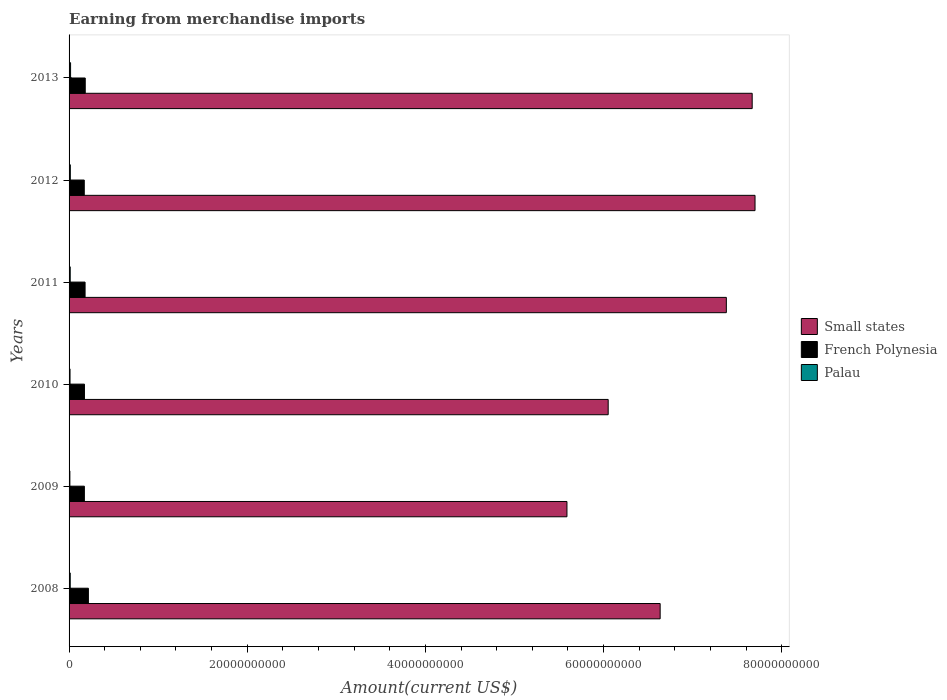How many different coloured bars are there?
Keep it short and to the point. 3. Are the number of bars on each tick of the Y-axis equal?
Your answer should be very brief. Yes. What is the amount earned from merchandise imports in Small states in 2008?
Your answer should be compact. 6.63e+1. Across all years, what is the maximum amount earned from merchandise imports in Small states?
Ensure brevity in your answer.  7.70e+1. Across all years, what is the minimum amount earned from merchandise imports in Small states?
Your answer should be compact. 5.59e+1. What is the total amount earned from merchandise imports in Palau in the graph?
Provide a short and direct response. 7.67e+08. What is the difference between the amount earned from merchandise imports in Small states in 2009 and that in 2011?
Offer a very short reply. -1.79e+1. What is the difference between the amount earned from merchandise imports in French Polynesia in 2009 and the amount earned from merchandise imports in Small states in 2013?
Provide a succinct answer. -7.50e+1. What is the average amount earned from merchandise imports in French Polynesia per year?
Your answer should be very brief. 1.82e+09. In the year 2013, what is the difference between the amount earned from merchandise imports in Small states and amount earned from merchandise imports in French Polynesia?
Offer a terse response. 7.49e+1. In how many years, is the amount earned from merchandise imports in Palau greater than 36000000000 US$?
Keep it short and to the point. 0. What is the ratio of the amount earned from merchandise imports in Small states in 2009 to that in 2012?
Offer a very short reply. 0.73. Is the amount earned from merchandise imports in Small states in 2009 less than that in 2011?
Ensure brevity in your answer.  Yes. What is the difference between the highest and the second highest amount earned from merchandise imports in French Polynesia?
Your answer should be compact. 3.54e+08. What is the difference between the highest and the lowest amount earned from merchandise imports in French Polynesia?
Provide a short and direct response. 4.63e+08. What does the 3rd bar from the top in 2013 represents?
Provide a succinct answer. Small states. What does the 1st bar from the bottom in 2011 represents?
Give a very brief answer. Small states. Is it the case that in every year, the sum of the amount earned from merchandise imports in Small states and amount earned from merchandise imports in French Polynesia is greater than the amount earned from merchandise imports in Palau?
Give a very brief answer. Yes. How many years are there in the graph?
Provide a succinct answer. 6. Are the values on the major ticks of X-axis written in scientific E-notation?
Ensure brevity in your answer.  No. Does the graph contain any zero values?
Ensure brevity in your answer.  No. Does the graph contain grids?
Your answer should be compact. No. How are the legend labels stacked?
Provide a short and direct response. Vertical. What is the title of the graph?
Your answer should be very brief. Earning from merchandise imports. What is the label or title of the X-axis?
Keep it short and to the point. Amount(current US$). What is the label or title of the Y-axis?
Your answer should be very brief. Years. What is the Amount(current US$) in Small states in 2008?
Give a very brief answer. 6.63e+1. What is the Amount(current US$) in French Polynesia in 2008?
Make the answer very short. 2.17e+09. What is the Amount(current US$) in Palau in 2008?
Your response must be concise. 1.30e+08. What is the Amount(current US$) in Small states in 2009?
Offer a very short reply. 5.59e+1. What is the Amount(current US$) in French Polynesia in 2009?
Your answer should be very brief. 1.72e+09. What is the Amount(current US$) in Palau in 2009?
Offer a very short reply. 8.99e+07. What is the Amount(current US$) of Small states in 2010?
Ensure brevity in your answer.  6.05e+1. What is the Amount(current US$) of French Polynesia in 2010?
Your response must be concise. 1.73e+09. What is the Amount(current US$) in Palau in 2010?
Provide a short and direct response. 1.07e+08. What is the Amount(current US$) in Small states in 2011?
Provide a succinct answer. 7.38e+1. What is the Amount(current US$) in French Polynesia in 2011?
Make the answer very short. 1.80e+09. What is the Amount(current US$) in Palau in 2011?
Give a very brief answer. 1.29e+08. What is the Amount(current US$) of Small states in 2012?
Your answer should be very brief. 7.70e+1. What is the Amount(current US$) of French Polynesia in 2012?
Provide a short and direct response. 1.71e+09. What is the Amount(current US$) in Palau in 2012?
Ensure brevity in your answer.  1.42e+08. What is the Amount(current US$) of Small states in 2013?
Keep it short and to the point. 7.67e+1. What is the Amount(current US$) in French Polynesia in 2013?
Your answer should be compact. 1.81e+09. What is the Amount(current US$) of Palau in 2013?
Make the answer very short. 1.69e+08. Across all years, what is the maximum Amount(current US$) in Small states?
Provide a short and direct response. 7.70e+1. Across all years, what is the maximum Amount(current US$) of French Polynesia?
Keep it short and to the point. 2.17e+09. Across all years, what is the maximum Amount(current US$) in Palau?
Your answer should be compact. 1.69e+08. Across all years, what is the minimum Amount(current US$) in Small states?
Your answer should be compact. 5.59e+1. Across all years, what is the minimum Amount(current US$) in French Polynesia?
Ensure brevity in your answer.  1.71e+09. Across all years, what is the minimum Amount(current US$) of Palau?
Keep it short and to the point. 8.99e+07. What is the total Amount(current US$) in Small states in the graph?
Your response must be concise. 4.10e+11. What is the total Amount(current US$) of French Polynesia in the graph?
Offer a terse response. 1.09e+1. What is the total Amount(current US$) in Palau in the graph?
Your answer should be very brief. 7.67e+08. What is the difference between the Amount(current US$) in Small states in 2008 and that in 2009?
Make the answer very short. 1.05e+1. What is the difference between the Amount(current US$) in French Polynesia in 2008 and that in 2009?
Offer a very short reply. 4.52e+08. What is the difference between the Amount(current US$) in Palau in 2008 and that in 2009?
Offer a very short reply. 4.02e+07. What is the difference between the Amount(current US$) in Small states in 2008 and that in 2010?
Your response must be concise. 5.83e+09. What is the difference between the Amount(current US$) in French Polynesia in 2008 and that in 2010?
Give a very brief answer. 4.43e+08. What is the difference between the Amount(current US$) of Palau in 2008 and that in 2010?
Give a very brief answer. 2.29e+07. What is the difference between the Amount(current US$) in Small states in 2008 and that in 2011?
Provide a succinct answer. -7.43e+09. What is the difference between the Amount(current US$) in French Polynesia in 2008 and that in 2011?
Keep it short and to the point. 3.72e+08. What is the difference between the Amount(current US$) of Palau in 2008 and that in 2011?
Provide a short and direct response. 9.13e+05. What is the difference between the Amount(current US$) of Small states in 2008 and that in 2012?
Give a very brief answer. -1.06e+1. What is the difference between the Amount(current US$) of French Polynesia in 2008 and that in 2012?
Your response must be concise. 4.63e+08. What is the difference between the Amount(current US$) in Palau in 2008 and that in 2012?
Your answer should be compact. -1.18e+07. What is the difference between the Amount(current US$) of Small states in 2008 and that in 2013?
Provide a short and direct response. -1.03e+1. What is the difference between the Amount(current US$) of French Polynesia in 2008 and that in 2013?
Give a very brief answer. 3.54e+08. What is the difference between the Amount(current US$) in Palau in 2008 and that in 2013?
Make the answer very short. -3.85e+07. What is the difference between the Amount(current US$) in Small states in 2009 and that in 2010?
Provide a succinct answer. -4.63e+09. What is the difference between the Amount(current US$) of French Polynesia in 2009 and that in 2010?
Provide a short and direct response. -8.70e+06. What is the difference between the Amount(current US$) of Palau in 2009 and that in 2010?
Make the answer very short. -1.73e+07. What is the difference between the Amount(current US$) in Small states in 2009 and that in 2011?
Make the answer very short. -1.79e+1. What is the difference between the Amount(current US$) in French Polynesia in 2009 and that in 2011?
Provide a short and direct response. -7.94e+07. What is the difference between the Amount(current US$) in Palau in 2009 and that in 2011?
Give a very brief answer. -3.93e+07. What is the difference between the Amount(current US$) in Small states in 2009 and that in 2012?
Ensure brevity in your answer.  -2.11e+1. What is the difference between the Amount(current US$) of French Polynesia in 2009 and that in 2012?
Provide a succinct answer. 1.16e+07. What is the difference between the Amount(current US$) of Palau in 2009 and that in 2012?
Give a very brief answer. -5.20e+07. What is the difference between the Amount(current US$) in Small states in 2009 and that in 2013?
Your answer should be very brief. -2.08e+1. What is the difference between the Amount(current US$) of French Polynesia in 2009 and that in 2013?
Give a very brief answer. -9.78e+07. What is the difference between the Amount(current US$) of Palau in 2009 and that in 2013?
Your response must be concise. -7.87e+07. What is the difference between the Amount(current US$) of Small states in 2010 and that in 2011?
Provide a succinct answer. -1.33e+1. What is the difference between the Amount(current US$) of French Polynesia in 2010 and that in 2011?
Keep it short and to the point. -7.07e+07. What is the difference between the Amount(current US$) of Palau in 2010 and that in 2011?
Offer a very short reply. -2.20e+07. What is the difference between the Amount(current US$) of Small states in 2010 and that in 2012?
Offer a terse response. -1.65e+1. What is the difference between the Amount(current US$) of French Polynesia in 2010 and that in 2012?
Offer a very short reply. 2.03e+07. What is the difference between the Amount(current US$) in Palau in 2010 and that in 2012?
Your answer should be very brief. -3.47e+07. What is the difference between the Amount(current US$) of Small states in 2010 and that in 2013?
Make the answer very short. -1.62e+1. What is the difference between the Amount(current US$) in French Polynesia in 2010 and that in 2013?
Your answer should be compact. -8.91e+07. What is the difference between the Amount(current US$) in Palau in 2010 and that in 2013?
Keep it short and to the point. -6.14e+07. What is the difference between the Amount(current US$) of Small states in 2011 and that in 2012?
Provide a short and direct response. -3.22e+09. What is the difference between the Amount(current US$) in French Polynesia in 2011 and that in 2012?
Offer a terse response. 9.10e+07. What is the difference between the Amount(current US$) of Palau in 2011 and that in 2012?
Make the answer very short. -1.27e+07. What is the difference between the Amount(current US$) of Small states in 2011 and that in 2013?
Offer a terse response. -2.90e+09. What is the difference between the Amount(current US$) in French Polynesia in 2011 and that in 2013?
Provide a short and direct response. -1.84e+07. What is the difference between the Amount(current US$) in Palau in 2011 and that in 2013?
Offer a terse response. -3.94e+07. What is the difference between the Amount(current US$) of Small states in 2012 and that in 2013?
Your response must be concise. 3.20e+08. What is the difference between the Amount(current US$) of French Polynesia in 2012 and that in 2013?
Your response must be concise. -1.09e+08. What is the difference between the Amount(current US$) in Palau in 2012 and that in 2013?
Offer a terse response. -2.67e+07. What is the difference between the Amount(current US$) of Small states in 2008 and the Amount(current US$) of French Polynesia in 2009?
Provide a short and direct response. 6.46e+1. What is the difference between the Amount(current US$) of Small states in 2008 and the Amount(current US$) of Palau in 2009?
Your response must be concise. 6.63e+1. What is the difference between the Amount(current US$) in French Polynesia in 2008 and the Amount(current US$) in Palau in 2009?
Your answer should be very brief. 2.08e+09. What is the difference between the Amount(current US$) of Small states in 2008 and the Amount(current US$) of French Polynesia in 2010?
Offer a very short reply. 6.46e+1. What is the difference between the Amount(current US$) in Small states in 2008 and the Amount(current US$) in Palau in 2010?
Keep it short and to the point. 6.62e+1. What is the difference between the Amount(current US$) in French Polynesia in 2008 and the Amount(current US$) in Palau in 2010?
Offer a very short reply. 2.06e+09. What is the difference between the Amount(current US$) of Small states in 2008 and the Amount(current US$) of French Polynesia in 2011?
Make the answer very short. 6.46e+1. What is the difference between the Amount(current US$) in Small states in 2008 and the Amount(current US$) in Palau in 2011?
Give a very brief answer. 6.62e+1. What is the difference between the Amount(current US$) of French Polynesia in 2008 and the Amount(current US$) of Palau in 2011?
Provide a short and direct response. 2.04e+09. What is the difference between the Amount(current US$) of Small states in 2008 and the Amount(current US$) of French Polynesia in 2012?
Provide a short and direct response. 6.46e+1. What is the difference between the Amount(current US$) of Small states in 2008 and the Amount(current US$) of Palau in 2012?
Offer a very short reply. 6.62e+1. What is the difference between the Amount(current US$) of French Polynesia in 2008 and the Amount(current US$) of Palau in 2012?
Your response must be concise. 2.03e+09. What is the difference between the Amount(current US$) in Small states in 2008 and the Amount(current US$) in French Polynesia in 2013?
Keep it short and to the point. 6.45e+1. What is the difference between the Amount(current US$) of Small states in 2008 and the Amount(current US$) of Palau in 2013?
Your answer should be very brief. 6.62e+1. What is the difference between the Amount(current US$) of French Polynesia in 2008 and the Amount(current US$) of Palau in 2013?
Offer a very short reply. 2.00e+09. What is the difference between the Amount(current US$) of Small states in 2009 and the Amount(current US$) of French Polynesia in 2010?
Provide a succinct answer. 5.42e+1. What is the difference between the Amount(current US$) in Small states in 2009 and the Amount(current US$) in Palau in 2010?
Offer a very short reply. 5.58e+1. What is the difference between the Amount(current US$) in French Polynesia in 2009 and the Amount(current US$) in Palau in 2010?
Your answer should be compact. 1.61e+09. What is the difference between the Amount(current US$) in Small states in 2009 and the Amount(current US$) in French Polynesia in 2011?
Provide a short and direct response. 5.41e+1. What is the difference between the Amount(current US$) in Small states in 2009 and the Amount(current US$) in Palau in 2011?
Your answer should be very brief. 5.58e+1. What is the difference between the Amount(current US$) of French Polynesia in 2009 and the Amount(current US$) of Palau in 2011?
Provide a succinct answer. 1.59e+09. What is the difference between the Amount(current US$) in Small states in 2009 and the Amount(current US$) in French Polynesia in 2012?
Keep it short and to the point. 5.42e+1. What is the difference between the Amount(current US$) in Small states in 2009 and the Amount(current US$) in Palau in 2012?
Ensure brevity in your answer.  5.57e+1. What is the difference between the Amount(current US$) of French Polynesia in 2009 and the Amount(current US$) of Palau in 2012?
Your answer should be compact. 1.58e+09. What is the difference between the Amount(current US$) of Small states in 2009 and the Amount(current US$) of French Polynesia in 2013?
Ensure brevity in your answer.  5.41e+1. What is the difference between the Amount(current US$) of Small states in 2009 and the Amount(current US$) of Palau in 2013?
Provide a short and direct response. 5.57e+1. What is the difference between the Amount(current US$) in French Polynesia in 2009 and the Amount(current US$) in Palau in 2013?
Keep it short and to the point. 1.55e+09. What is the difference between the Amount(current US$) in Small states in 2010 and the Amount(current US$) in French Polynesia in 2011?
Offer a very short reply. 5.87e+1. What is the difference between the Amount(current US$) of Small states in 2010 and the Amount(current US$) of Palau in 2011?
Your answer should be compact. 6.04e+1. What is the difference between the Amount(current US$) of French Polynesia in 2010 and the Amount(current US$) of Palau in 2011?
Give a very brief answer. 1.60e+09. What is the difference between the Amount(current US$) in Small states in 2010 and the Amount(current US$) in French Polynesia in 2012?
Your response must be concise. 5.88e+1. What is the difference between the Amount(current US$) of Small states in 2010 and the Amount(current US$) of Palau in 2012?
Keep it short and to the point. 6.04e+1. What is the difference between the Amount(current US$) in French Polynesia in 2010 and the Amount(current US$) in Palau in 2012?
Provide a short and direct response. 1.58e+09. What is the difference between the Amount(current US$) in Small states in 2010 and the Amount(current US$) in French Polynesia in 2013?
Ensure brevity in your answer.  5.87e+1. What is the difference between the Amount(current US$) of Small states in 2010 and the Amount(current US$) of Palau in 2013?
Provide a succinct answer. 6.03e+1. What is the difference between the Amount(current US$) of French Polynesia in 2010 and the Amount(current US$) of Palau in 2013?
Your answer should be very brief. 1.56e+09. What is the difference between the Amount(current US$) in Small states in 2011 and the Amount(current US$) in French Polynesia in 2012?
Provide a succinct answer. 7.21e+1. What is the difference between the Amount(current US$) in Small states in 2011 and the Amount(current US$) in Palau in 2012?
Provide a short and direct response. 7.36e+1. What is the difference between the Amount(current US$) in French Polynesia in 2011 and the Amount(current US$) in Palau in 2012?
Your answer should be compact. 1.65e+09. What is the difference between the Amount(current US$) of Small states in 2011 and the Amount(current US$) of French Polynesia in 2013?
Offer a terse response. 7.20e+1. What is the difference between the Amount(current US$) in Small states in 2011 and the Amount(current US$) in Palau in 2013?
Offer a terse response. 7.36e+1. What is the difference between the Amount(current US$) of French Polynesia in 2011 and the Amount(current US$) of Palau in 2013?
Offer a very short reply. 1.63e+09. What is the difference between the Amount(current US$) in Small states in 2012 and the Amount(current US$) in French Polynesia in 2013?
Your answer should be compact. 7.52e+1. What is the difference between the Amount(current US$) in Small states in 2012 and the Amount(current US$) in Palau in 2013?
Make the answer very short. 7.68e+1. What is the difference between the Amount(current US$) in French Polynesia in 2012 and the Amount(current US$) in Palau in 2013?
Provide a succinct answer. 1.54e+09. What is the average Amount(current US$) of Small states per year?
Ensure brevity in your answer.  6.84e+1. What is the average Amount(current US$) in French Polynesia per year?
Your answer should be very brief. 1.82e+09. What is the average Amount(current US$) in Palau per year?
Ensure brevity in your answer.  1.28e+08. In the year 2008, what is the difference between the Amount(current US$) of Small states and Amount(current US$) of French Polynesia?
Your answer should be very brief. 6.42e+1. In the year 2008, what is the difference between the Amount(current US$) of Small states and Amount(current US$) of Palau?
Make the answer very short. 6.62e+1. In the year 2008, what is the difference between the Amount(current US$) of French Polynesia and Amount(current US$) of Palau?
Keep it short and to the point. 2.04e+09. In the year 2009, what is the difference between the Amount(current US$) of Small states and Amount(current US$) of French Polynesia?
Offer a very short reply. 5.42e+1. In the year 2009, what is the difference between the Amount(current US$) of Small states and Amount(current US$) of Palau?
Your response must be concise. 5.58e+1. In the year 2009, what is the difference between the Amount(current US$) in French Polynesia and Amount(current US$) in Palau?
Your response must be concise. 1.63e+09. In the year 2010, what is the difference between the Amount(current US$) of Small states and Amount(current US$) of French Polynesia?
Ensure brevity in your answer.  5.88e+1. In the year 2010, what is the difference between the Amount(current US$) in Small states and Amount(current US$) in Palau?
Offer a very short reply. 6.04e+1. In the year 2010, what is the difference between the Amount(current US$) in French Polynesia and Amount(current US$) in Palau?
Your answer should be very brief. 1.62e+09. In the year 2011, what is the difference between the Amount(current US$) of Small states and Amount(current US$) of French Polynesia?
Your answer should be compact. 7.20e+1. In the year 2011, what is the difference between the Amount(current US$) of Small states and Amount(current US$) of Palau?
Offer a terse response. 7.36e+1. In the year 2011, what is the difference between the Amount(current US$) of French Polynesia and Amount(current US$) of Palau?
Give a very brief answer. 1.67e+09. In the year 2012, what is the difference between the Amount(current US$) in Small states and Amount(current US$) in French Polynesia?
Offer a terse response. 7.53e+1. In the year 2012, what is the difference between the Amount(current US$) of Small states and Amount(current US$) of Palau?
Your response must be concise. 7.69e+1. In the year 2012, what is the difference between the Amount(current US$) in French Polynesia and Amount(current US$) in Palau?
Ensure brevity in your answer.  1.56e+09. In the year 2013, what is the difference between the Amount(current US$) in Small states and Amount(current US$) in French Polynesia?
Give a very brief answer. 7.49e+1. In the year 2013, what is the difference between the Amount(current US$) in Small states and Amount(current US$) in Palau?
Keep it short and to the point. 7.65e+1. In the year 2013, what is the difference between the Amount(current US$) in French Polynesia and Amount(current US$) in Palau?
Give a very brief answer. 1.65e+09. What is the ratio of the Amount(current US$) of Small states in 2008 to that in 2009?
Your response must be concise. 1.19. What is the ratio of the Amount(current US$) of French Polynesia in 2008 to that in 2009?
Provide a short and direct response. 1.26. What is the ratio of the Amount(current US$) in Palau in 2008 to that in 2009?
Ensure brevity in your answer.  1.45. What is the ratio of the Amount(current US$) of Small states in 2008 to that in 2010?
Give a very brief answer. 1.1. What is the ratio of the Amount(current US$) of French Polynesia in 2008 to that in 2010?
Your answer should be very brief. 1.26. What is the ratio of the Amount(current US$) of Palau in 2008 to that in 2010?
Provide a succinct answer. 1.21. What is the ratio of the Amount(current US$) in Small states in 2008 to that in 2011?
Provide a short and direct response. 0.9. What is the ratio of the Amount(current US$) of French Polynesia in 2008 to that in 2011?
Ensure brevity in your answer.  1.21. What is the ratio of the Amount(current US$) of Palau in 2008 to that in 2011?
Ensure brevity in your answer.  1.01. What is the ratio of the Amount(current US$) in Small states in 2008 to that in 2012?
Offer a very short reply. 0.86. What is the ratio of the Amount(current US$) in French Polynesia in 2008 to that in 2012?
Keep it short and to the point. 1.27. What is the ratio of the Amount(current US$) in Palau in 2008 to that in 2012?
Provide a succinct answer. 0.92. What is the ratio of the Amount(current US$) of Small states in 2008 to that in 2013?
Your answer should be very brief. 0.87. What is the ratio of the Amount(current US$) of French Polynesia in 2008 to that in 2013?
Provide a succinct answer. 1.2. What is the ratio of the Amount(current US$) in Palau in 2008 to that in 2013?
Ensure brevity in your answer.  0.77. What is the ratio of the Amount(current US$) of Small states in 2009 to that in 2010?
Keep it short and to the point. 0.92. What is the ratio of the Amount(current US$) in Palau in 2009 to that in 2010?
Your answer should be compact. 0.84. What is the ratio of the Amount(current US$) of Small states in 2009 to that in 2011?
Provide a succinct answer. 0.76. What is the ratio of the Amount(current US$) in French Polynesia in 2009 to that in 2011?
Provide a short and direct response. 0.96. What is the ratio of the Amount(current US$) in Palau in 2009 to that in 2011?
Provide a succinct answer. 0.7. What is the ratio of the Amount(current US$) of Small states in 2009 to that in 2012?
Your answer should be very brief. 0.73. What is the ratio of the Amount(current US$) in French Polynesia in 2009 to that in 2012?
Keep it short and to the point. 1.01. What is the ratio of the Amount(current US$) of Palau in 2009 to that in 2012?
Offer a terse response. 0.63. What is the ratio of the Amount(current US$) in Small states in 2009 to that in 2013?
Offer a terse response. 0.73. What is the ratio of the Amount(current US$) of French Polynesia in 2009 to that in 2013?
Your answer should be very brief. 0.95. What is the ratio of the Amount(current US$) in Palau in 2009 to that in 2013?
Give a very brief answer. 0.53. What is the ratio of the Amount(current US$) of Small states in 2010 to that in 2011?
Offer a terse response. 0.82. What is the ratio of the Amount(current US$) of French Polynesia in 2010 to that in 2011?
Offer a terse response. 0.96. What is the ratio of the Amount(current US$) in Palau in 2010 to that in 2011?
Offer a terse response. 0.83. What is the ratio of the Amount(current US$) in Small states in 2010 to that in 2012?
Offer a very short reply. 0.79. What is the ratio of the Amount(current US$) in French Polynesia in 2010 to that in 2012?
Make the answer very short. 1.01. What is the ratio of the Amount(current US$) in Palau in 2010 to that in 2012?
Provide a succinct answer. 0.76. What is the ratio of the Amount(current US$) of Small states in 2010 to that in 2013?
Your response must be concise. 0.79. What is the ratio of the Amount(current US$) of French Polynesia in 2010 to that in 2013?
Your answer should be very brief. 0.95. What is the ratio of the Amount(current US$) in Palau in 2010 to that in 2013?
Give a very brief answer. 0.64. What is the ratio of the Amount(current US$) in Small states in 2011 to that in 2012?
Offer a terse response. 0.96. What is the ratio of the Amount(current US$) of French Polynesia in 2011 to that in 2012?
Provide a succinct answer. 1.05. What is the ratio of the Amount(current US$) of Palau in 2011 to that in 2012?
Provide a succinct answer. 0.91. What is the ratio of the Amount(current US$) of Small states in 2011 to that in 2013?
Provide a succinct answer. 0.96. What is the ratio of the Amount(current US$) of French Polynesia in 2011 to that in 2013?
Provide a short and direct response. 0.99. What is the ratio of the Amount(current US$) of Palau in 2011 to that in 2013?
Provide a short and direct response. 0.77. What is the ratio of the Amount(current US$) in Small states in 2012 to that in 2013?
Make the answer very short. 1. What is the ratio of the Amount(current US$) in French Polynesia in 2012 to that in 2013?
Offer a very short reply. 0.94. What is the ratio of the Amount(current US$) in Palau in 2012 to that in 2013?
Give a very brief answer. 0.84. What is the difference between the highest and the second highest Amount(current US$) of Small states?
Your answer should be compact. 3.20e+08. What is the difference between the highest and the second highest Amount(current US$) in French Polynesia?
Keep it short and to the point. 3.54e+08. What is the difference between the highest and the second highest Amount(current US$) of Palau?
Ensure brevity in your answer.  2.67e+07. What is the difference between the highest and the lowest Amount(current US$) of Small states?
Keep it short and to the point. 2.11e+1. What is the difference between the highest and the lowest Amount(current US$) in French Polynesia?
Provide a succinct answer. 4.63e+08. What is the difference between the highest and the lowest Amount(current US$) of Palau?
Your answer should be compact. 7.87e+07. 